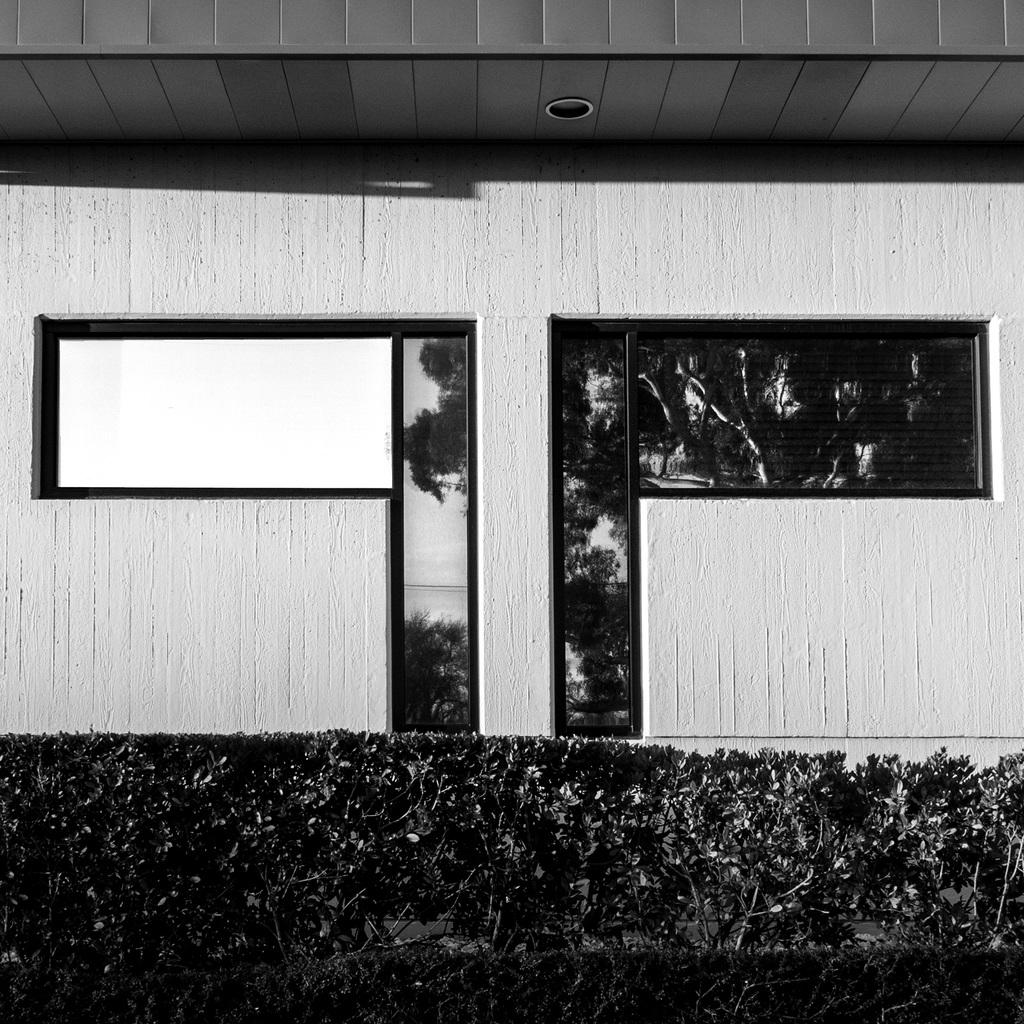What type of structure is visible in the image? There is a building in the image. What can be seen at the bottom of the image? There are plants at the bottom of the image. Can you touch the sail in the image? There is no sail present in the image. How many trees are visible in the image? The image does not show any trees; it only features a building and plants at the bottom. 